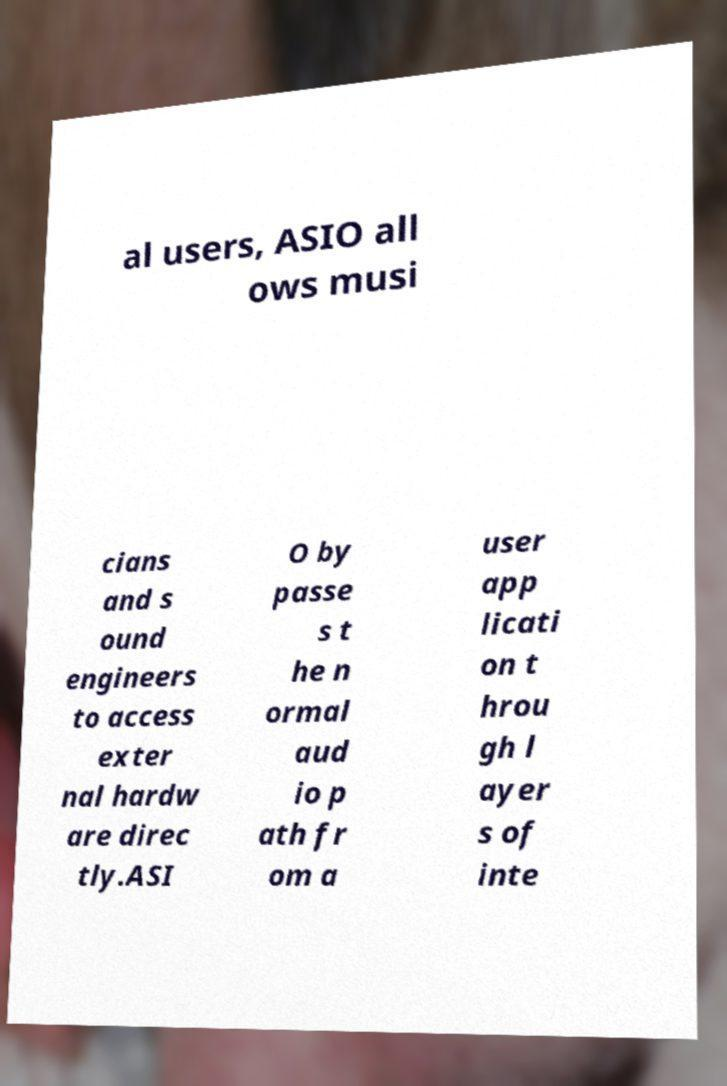For documentation purposes, I need the text within this image transcribed. Could you provide that? al users, ASIO all ows musi cians and s ound engineers to access exter nal hardw are direc tly.ASI O by passe s t he n ormal aud io p ath fr om a user app licati on t hrou gh l ayer s of inte 